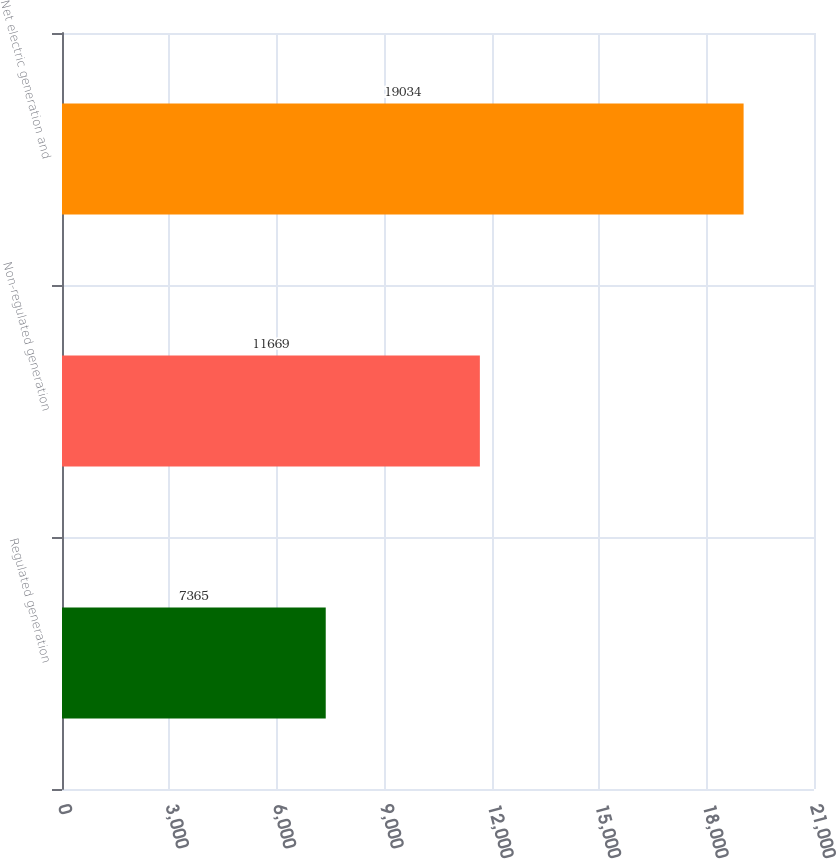Convert chart to OTSL. <chart><loc_0><loc_0><loc_500><loc_500><bar_chart><fcel>Regulated generation<fcel>Non-regulated generation<fcel>Net electric generation and<nl><fcel>7365<fcel>11669<fcel>19034<nl></chart> 